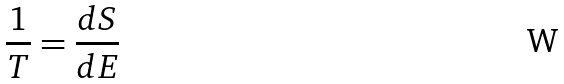Convert formula to latex. <formula><loc_0><loc_0><loc_500><loc_500>\frac { 1 } { T } = \frac { d S } { d E }</formula> 